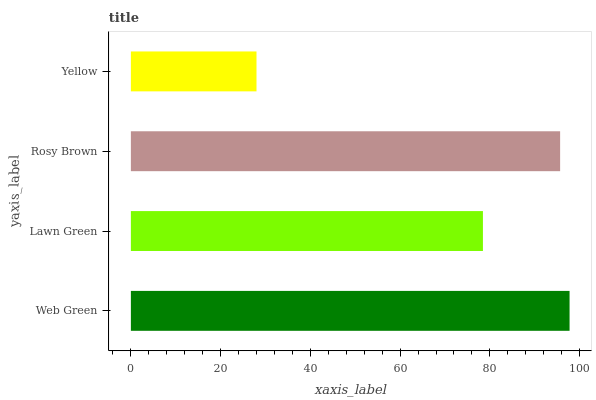Is Yellow the minimum?
Answer yes or no. Yes. Is Web Green the maximum?
Answer yes or no. Yes. Is Lawn Green the minimum?
Answer yes or no. No. Is Lawn Green the maximum?
Answer yes or no. No. Is Web Green greater than Lawn Green?
Answer yes or no. Yes. Is Lawn Green less than Web Green?
Answer yes or no. Yes. Is Lawn Green greater than Web Green?
Answer yes or no. No. Is Web Green less than Lawn Green?
Answer yes or no. No. Is Rosy Brown the high median?
Answer yes or no. Yes. Is Lawn Green the low median?
Answer yes or no. Yes. Is Lawn Green the high median?
Answer yes or no. No. Is Web Green the low median?
Answer yes or no. No. 